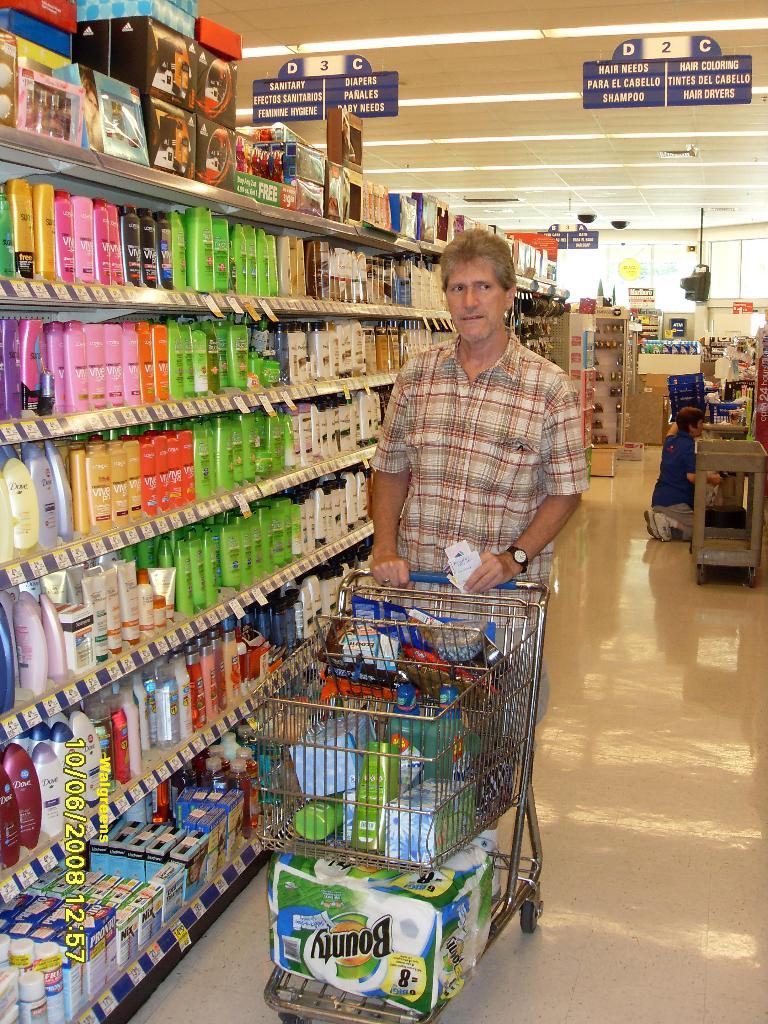What brand of towels located at the bottom of the cart did he buy?
Give a very brief answer. Bounty. What aisle is this man in?
Keep it short and to the point. 2. 